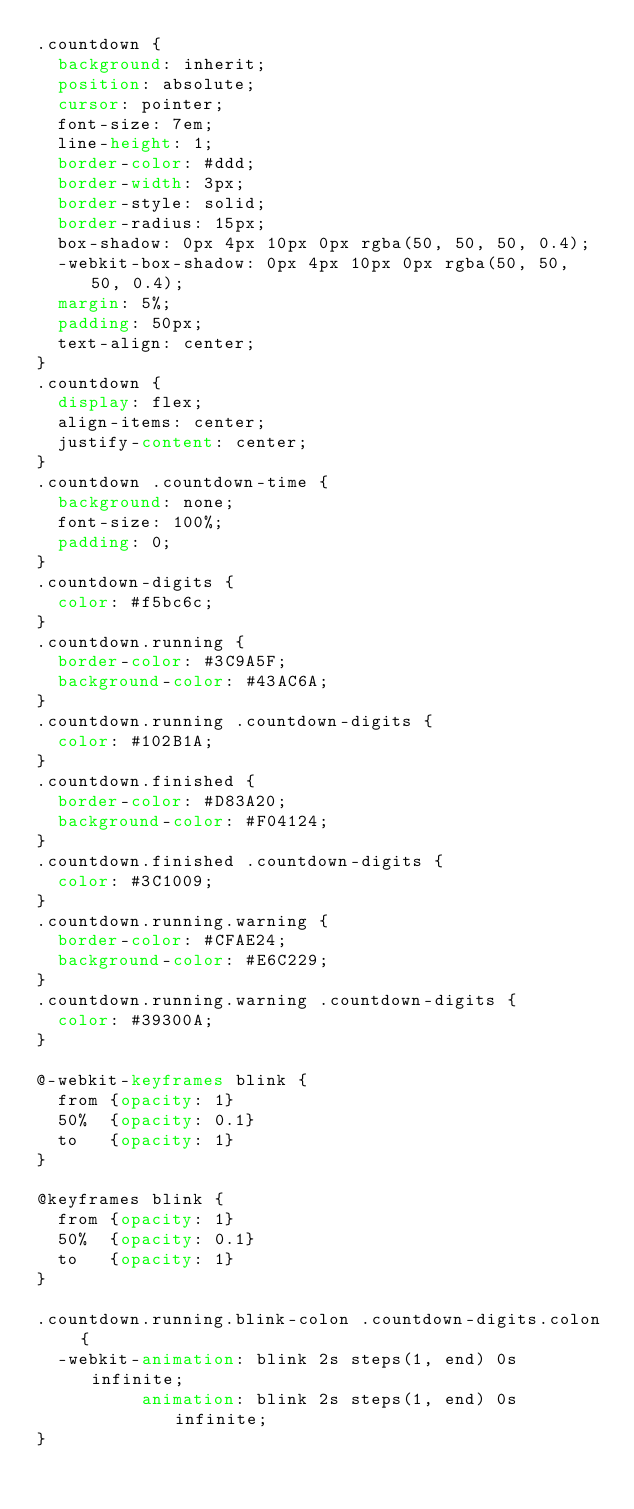<code> <loc_0><loc_0><loc_500><loc_500><_CSS_>.countdown {
  background: inherit;
  position: absolute;
  cursor: pointer;
  font-size: 7em;
  line-height: 1;
  border-color: #ddd;
  border-width: 3px;
  border-style: solid;
  border-radius: 15px;
  box-shadow: 0px 4px 10px 0px rgba(50, 50, 50, 0.4);
  -webkit-box-shadow: 0px 4px 10px 0px rgba(50, 50, 50, 0.4);
  margin: 5%;
  padding: 50px;
  text-align: center;
}
.countdown {
  display: flex;
  align-items: center;
  justify-content: center;
}
.countdown .countdown-time {
  background: none;
  font-size: 100%;
  padding: 0;
}
.countdown-digits {
  color: #f5bc6c;
}
.countdown.running {
  border-color: #3C9A5F;
  background-color: #43AC6A;
}
.countdown.running .countdown-digits {
  color: #102B1A;
}
.countdown.finished {
  border-color: #D83A20;
  background-color: #F04124;
}
.countdown.finished .countdown-digits {
  color: #3C1009;
}
.countdown.running.warning {
  border-color: #CFAE24;
  background-color: #E6C229;
}
.countdown.running.warning .countdown-digits {
  color: #39300A;
}

@-webkit-keyframes blink {
	from {opacity: 1}
	50%  {opacity: 0.1}
	to   {opacity: 1}
}

@keyframes blink {
	from {opacity: 1}
	50%  {opacity: 0.1}
	to   {opacity: 1}
}

.countdown.running.blink-colon .countdown-digits.colon {
  -webkit-animation: blink 2s steps(1, end) 0s infinite;
          animation: blink 2s steps(1, end) 0s infinite;
}
</code> 